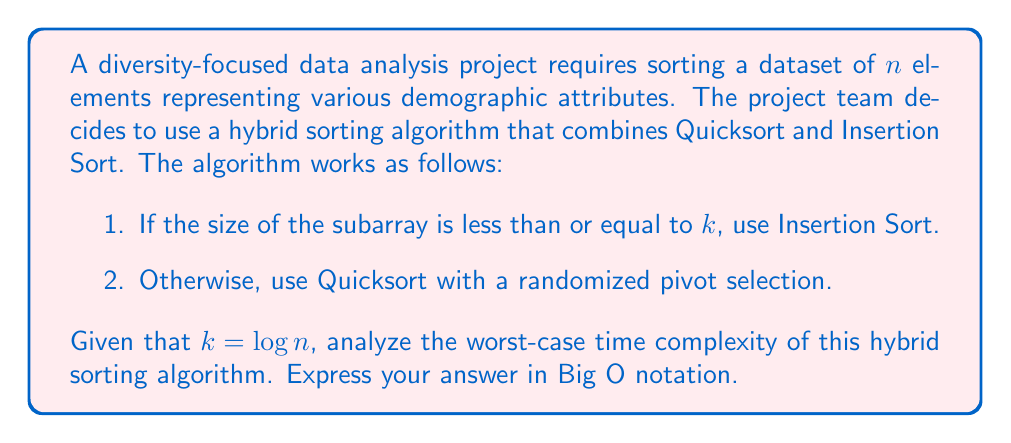Teach me how to tackle this problem. To analyze the worst-case time complexity of this hybrid sorting algorithm, we need to consider both the Quicksort and Insertion Sort components:

1. Quicksort:
   - In the worst case, Quicksort has a time complexity of $O(n^2)$.
   - However, with randomized pivot selection, the probability of encountering the worst case is significantly reduced.
   - The average-case time complexity of Quicksort is $O(n \log n)$.

2. Insertion Sort:
   - Insertion Sort has a worst-case time complexity of $O(m^2)$, where $m$ is the size of the subarray.
   - In this case, $m = k = \log n$.

Now, let's analyze the hybrid algorithm:

- The algorithm switches to Insertion Sort when the subarray size is $\leq \log n$.
- This means that Quicksort will be used for larger subarrays, and Insertion Sort for smaller ones.

In the worst case:
- Quicksort will partition the array $\log n$ times before reaching subarrays of size $\log n$.
- For each of these partitions, we perform $O(n)$ comparisons.
- After reaching subarrays of size $\log n$, we use Insertion Sort.

The total time complexity can be expressed as:

$$ T(n) = O(n \log n) + O(n) \cdot O((\log n)^2) $$

The first term $O(n \log n)$ represents the Quicksort partitioning.
The second term $O(n) \cdot O((\log n)^2)$ represents the Insertion Sort operations:
- $O(n)$ subarrays of size $\log n$
- Each subarray takes $O((\log n)^2)$ time to sort

Simplifying:

$$ T(n) = O(n \log n) + O(n (\log n)^2) $$

The dominant term is $O(n (\log n)^2)$, which represents the worst-case time complexity of this hybrid sorting algorithm.
Answer: $O(n (\log n)^2)$ 